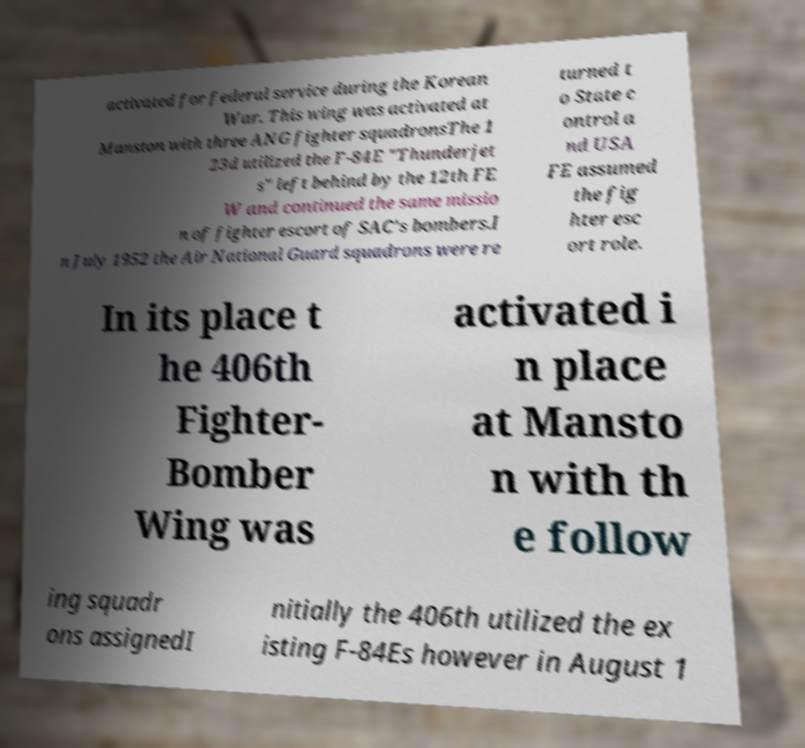I need the written content from this picture converted into text. Can you do that? activated for federal service during the Korean War. This wing was activated at Manston with three ANG fighter squadronsThe 1 23d utilized the F-84E "Thunderjet s" left behind by the 12th FE W and continued the same missio n of fighter escort of SAC's bombers.I n July 1952 the Air National Guard squadrons were re turned t o State c ontrol a nd USA FE assumed the fig hter esc ort role. In its place t he 406th Fighter- Bomber Wing was activated i n place at Mansto n with th e follow ing squadr ons assignedI nitially the 406th utilized the ex isting F-84Es however in August 1 